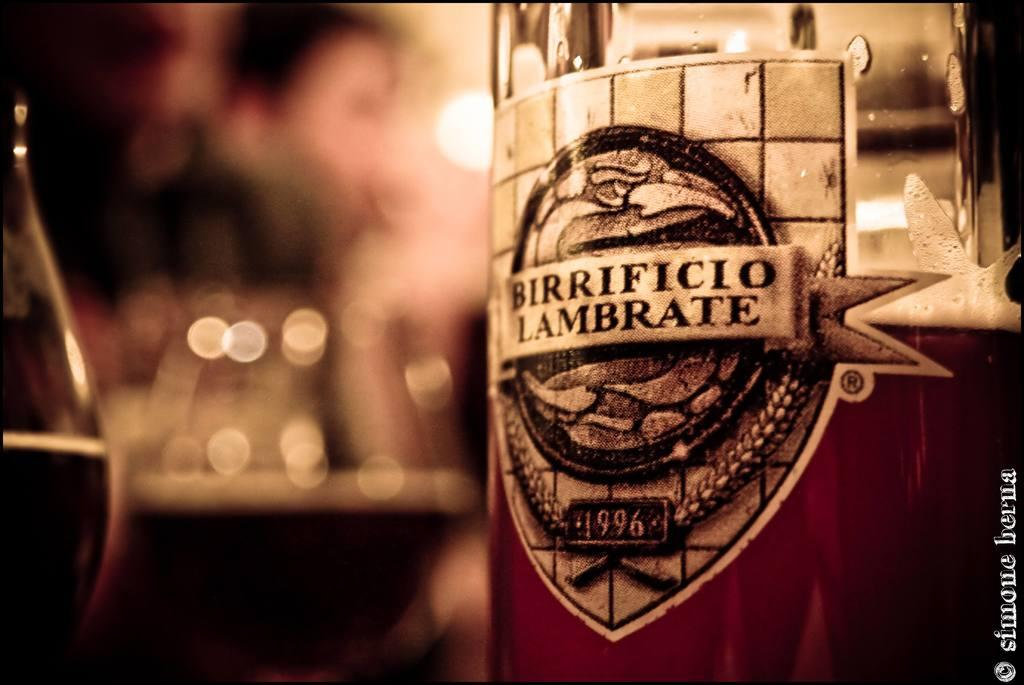<image>
Describe the image concisely. A half empty bottle of Birrificio Lambrate is sitting next to a few half full glasses. 